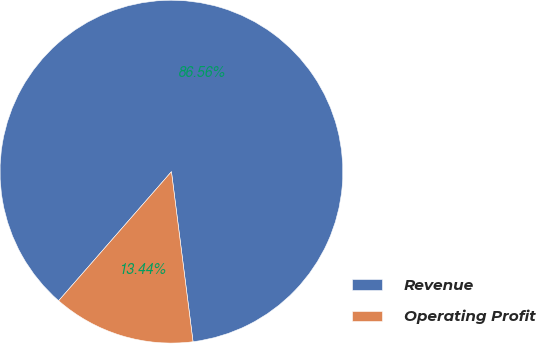Convert chart. <chart><loc_0><loc_0><loc_500><loc_500><pie_chart><fcel>Revenue<fcel>Operating Profit<nl><fcel>86.56%<fcel>13.44%<nl></chart> 